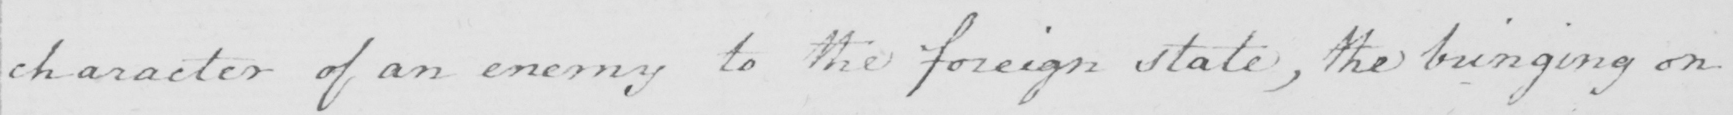Transcribe the text shown in this historical manuscript line. character of an enemy to the foreign state , the bringing on 